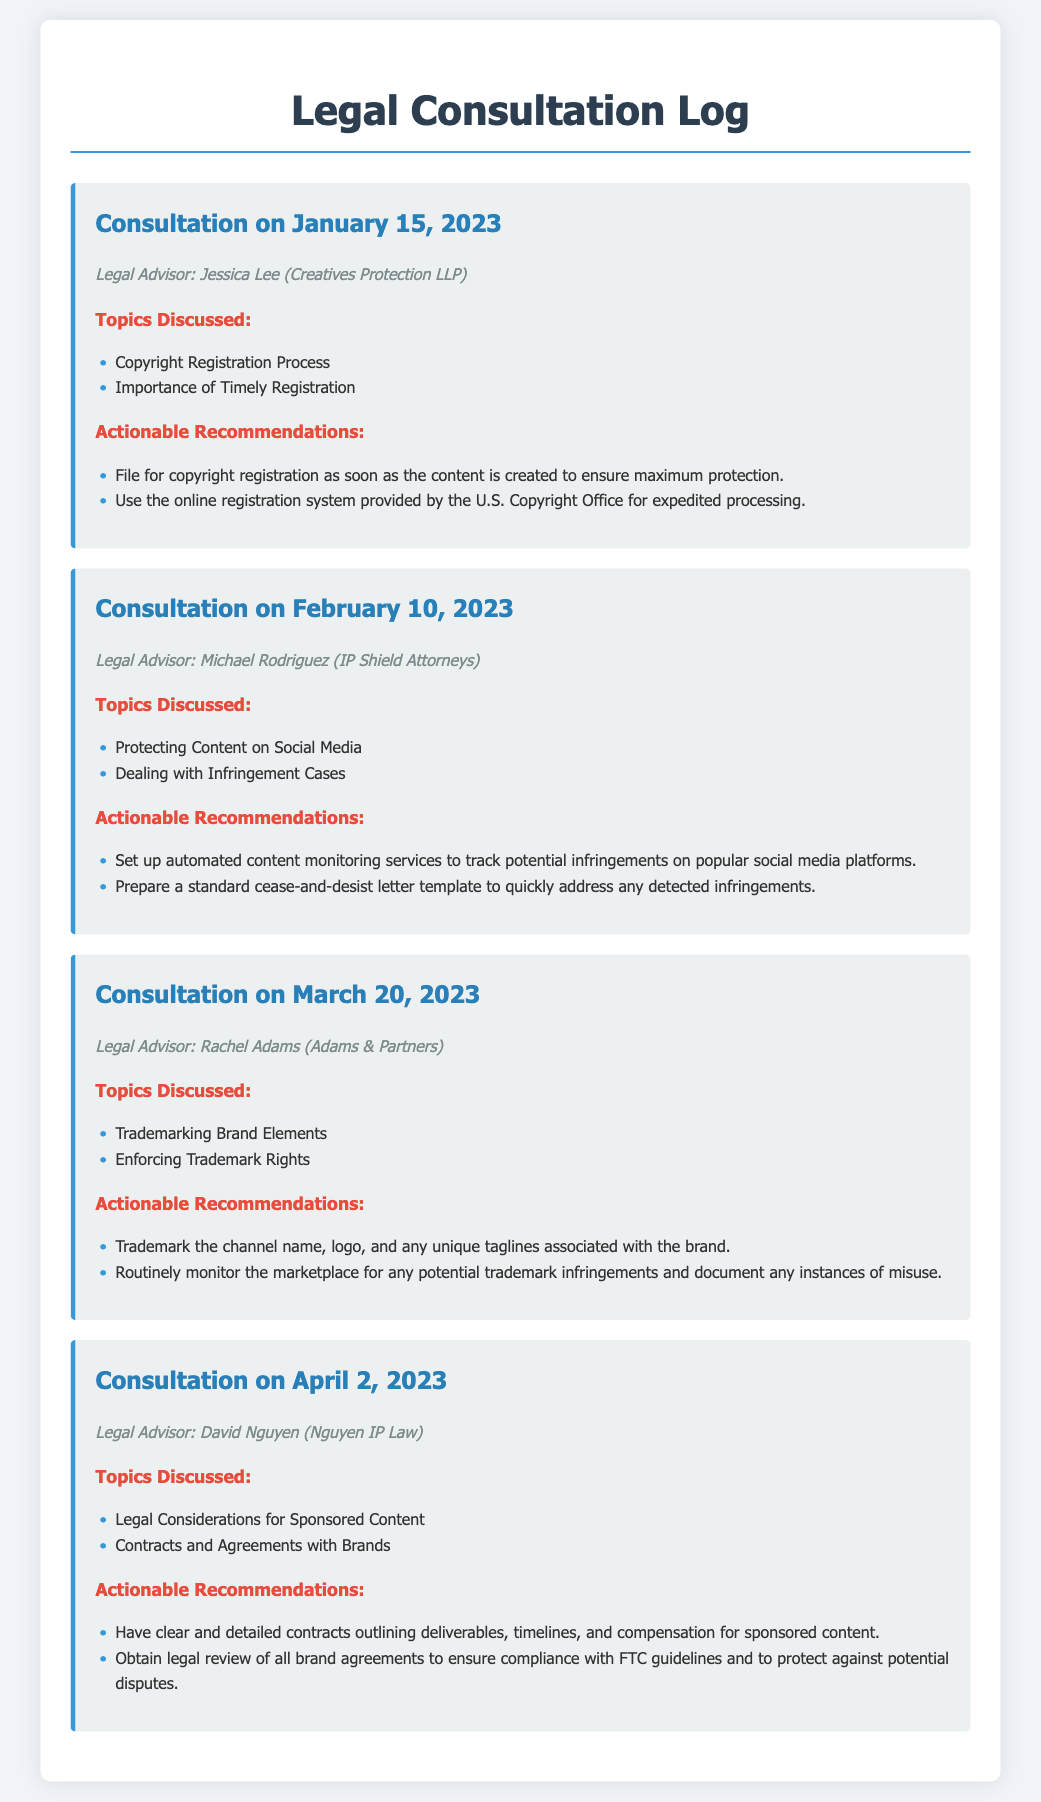What is the date of the first consultation? The date of the first consultation, as listed in the log, is January 15, 2023.
Answer: January 15, 2023 Who was the legal advisor for the February 10, 2023 consultation? The legal advisor for the February 10, 2023 consultation is Michael Rodriguez.
Answer: Michael Rodriguez What topic was discussed in the March 20, 2023 consultation? One of the topics discussed in the March 20, 2023 consultation is Trademarking Brand Elements.
Answer: Trademarking Brand Elements What is one actionable recommendation from the consultation on April 2, 2023? One actionable recommendation from the consultation on April 2, 2023 is to have clear and detailed contracts outlining deliverables, timelines, and compensation for sponsored content.
Answer: Have clear and detailed contracts How many consultations are documented? The document lists a total of four consultations.
Answer: Four What is the name of the legal advisor mentioned in the first consultation? The name of the legal advisor mentioned in the first consultation is Jessica Lee.
Answer: Jessica Lee Which legal advisor discussed protecting content on social media? The legal advisor who discussed protecting content on social media is Michael Rodriguez.
Answer: Michael Rodriguez What did the advisor recommend about trademarking? The advisor recommended to trademark the channel name, logo, and any unique taglines associated with the brand.
Answer: Trademark the channel name, logo, and taglines What is the primary purpose of this document? The primary purpose of this document is to maintain a log of legal consultations with detailed records.
Answer: Maintain a log of legal consultations 